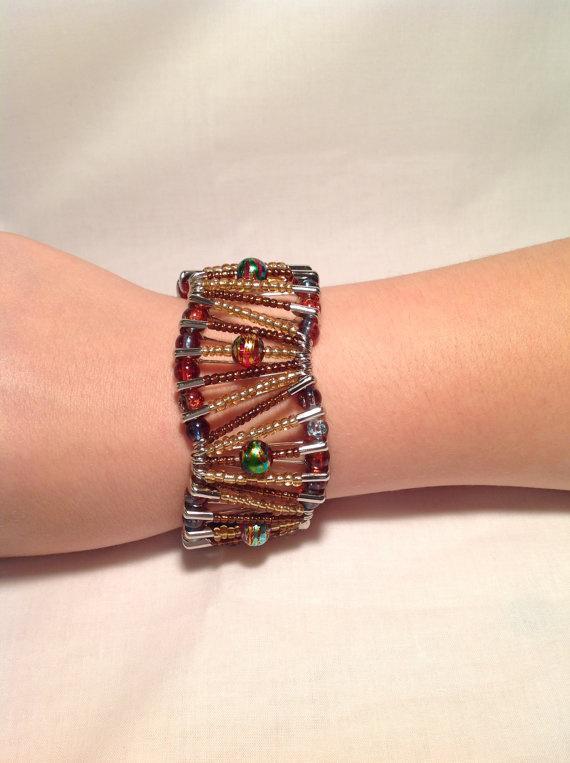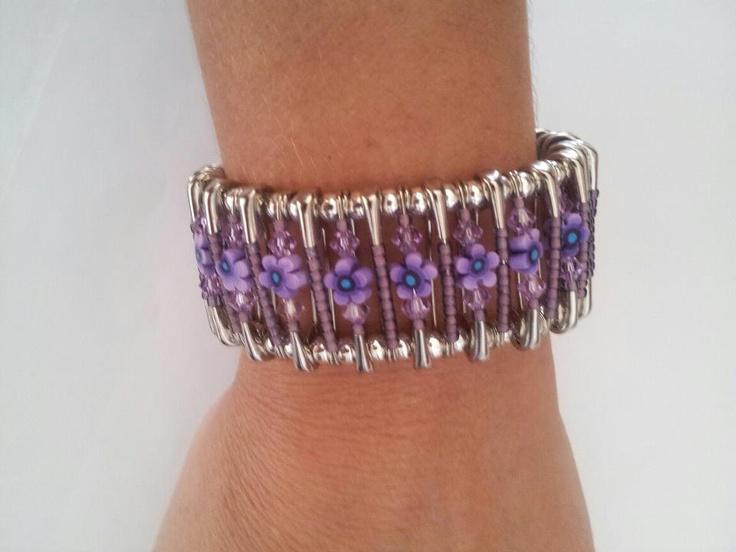The first image is the image on the left, the second image is the image on the right. Assess this claim about the two images: "An image shows an unworn bracelet made of silver safety pins strung with different bead colors.". Correct or not? Answer yes or no. No. The first image is the image on the left, the second image is the image on the right. Evaluate the accuracy of this statement regarding the images: "there is a human wearing a bracelet in each image.". Is it true? Answer yes or no. Yes. 